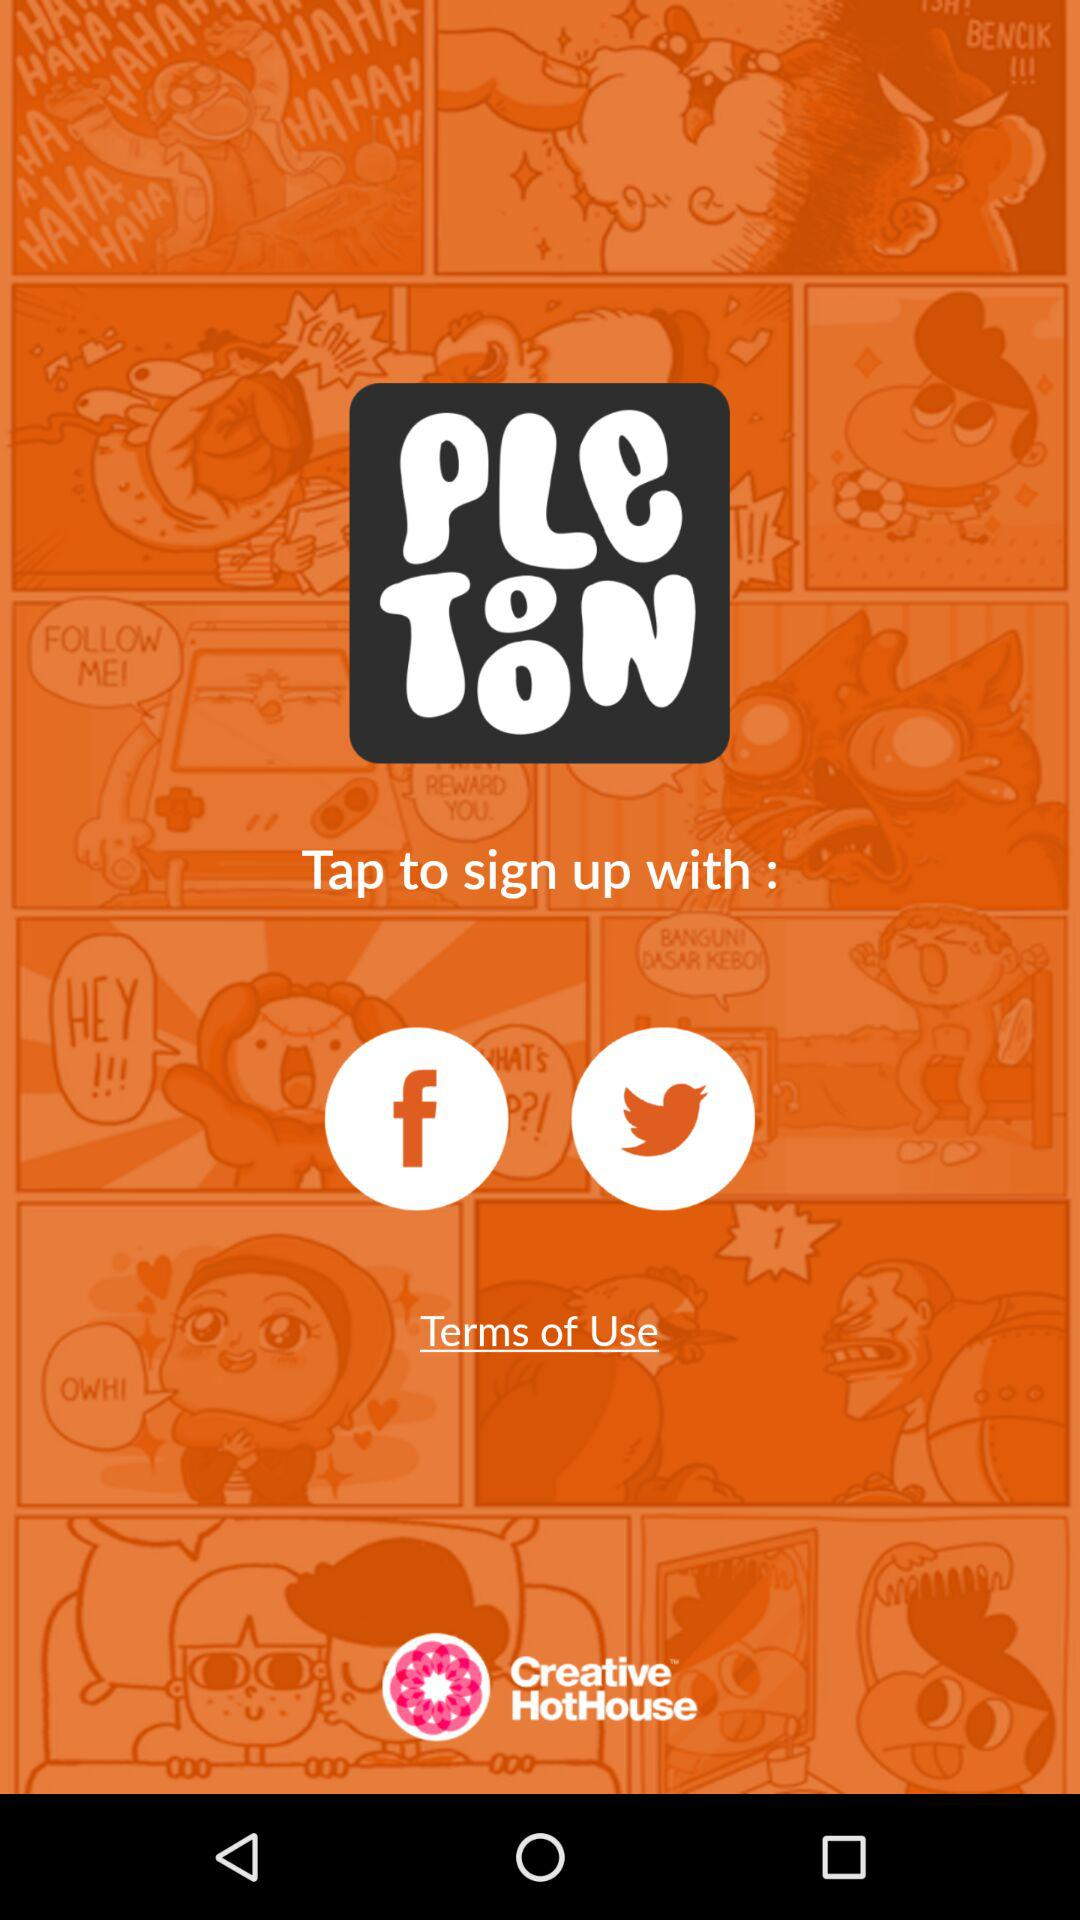Which account should I use to continue with? You can use "facebook" or "twitter" to continue with. 